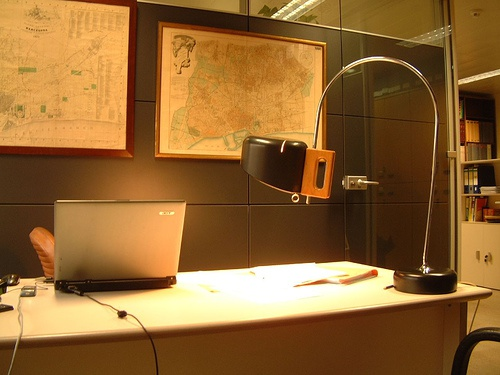Describe the objects in this image and their specific colors. I can see laptop in orange, olive, tan, and black tones, chair in orange, black, maroon, and olive tones, chair in orange, brown, and maroon tones, book in orange, olive, maroon, and black tones, and book in orange, maroon, brown, and black tones in this image. 